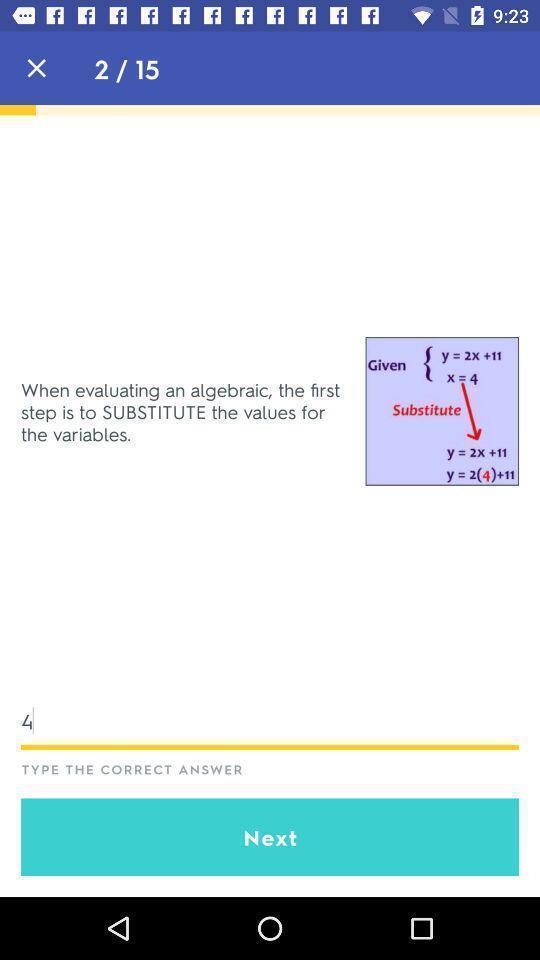Explain what's happening in this screen capture. Question page displaying to type an answer. 